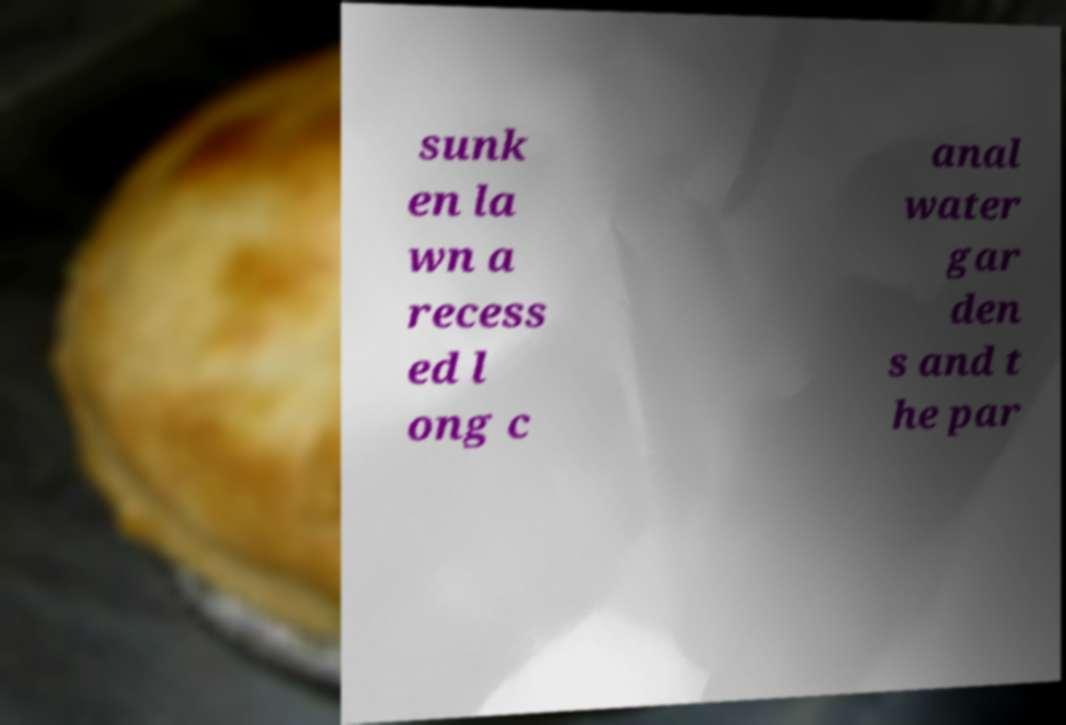Can you read and provide the text displayed in the image?This photo seems to have some interesting text. Can you extract and type it out for me? sunk en la wn a recess ed l ong c anal water gar den s and t he par 